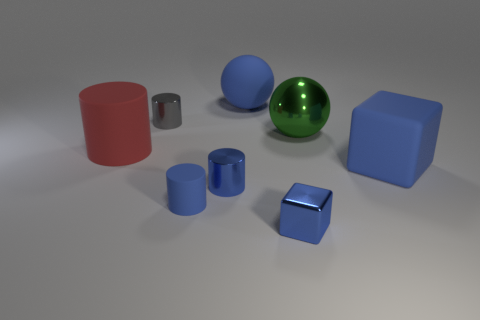How many rubber things are either gray cylinders or tiny red cylinders?
Make the answer very short. 0. What is the color of the other matte object that is the same shape as the large green thing?
Keep it short and to the point. Blue. How many things are metallic balls or red balls?
Your answer should be very brief. 1. The large blue object that is the same material as the blue sphere is what shape?
Your answer should be compact. Cube. What number of small things are either red metal objects or blue matte spheres?
Give a very brief answer. 0. How many other things are there of the same color as the tiny metal block?
Keep it short and to the point. 4. There is a large blue rubber object that is in front of the rubber object that is on the left side of the gray object; what number of shiny cylinders are right of it?
Offer a terse response. 0. Does the matte thing to the right of the matte sphere have the same size as the tiny matte cylinder?
Give a very brief answer. No. Is the number of green metallic balls on the right side of the green object less than the number of rubber objects left of the large red rubber cylinder?
Make the answer very short. No. Is the tiny matte cylinder the same color as the matte ball?
Offer a very short reply. Yes. 